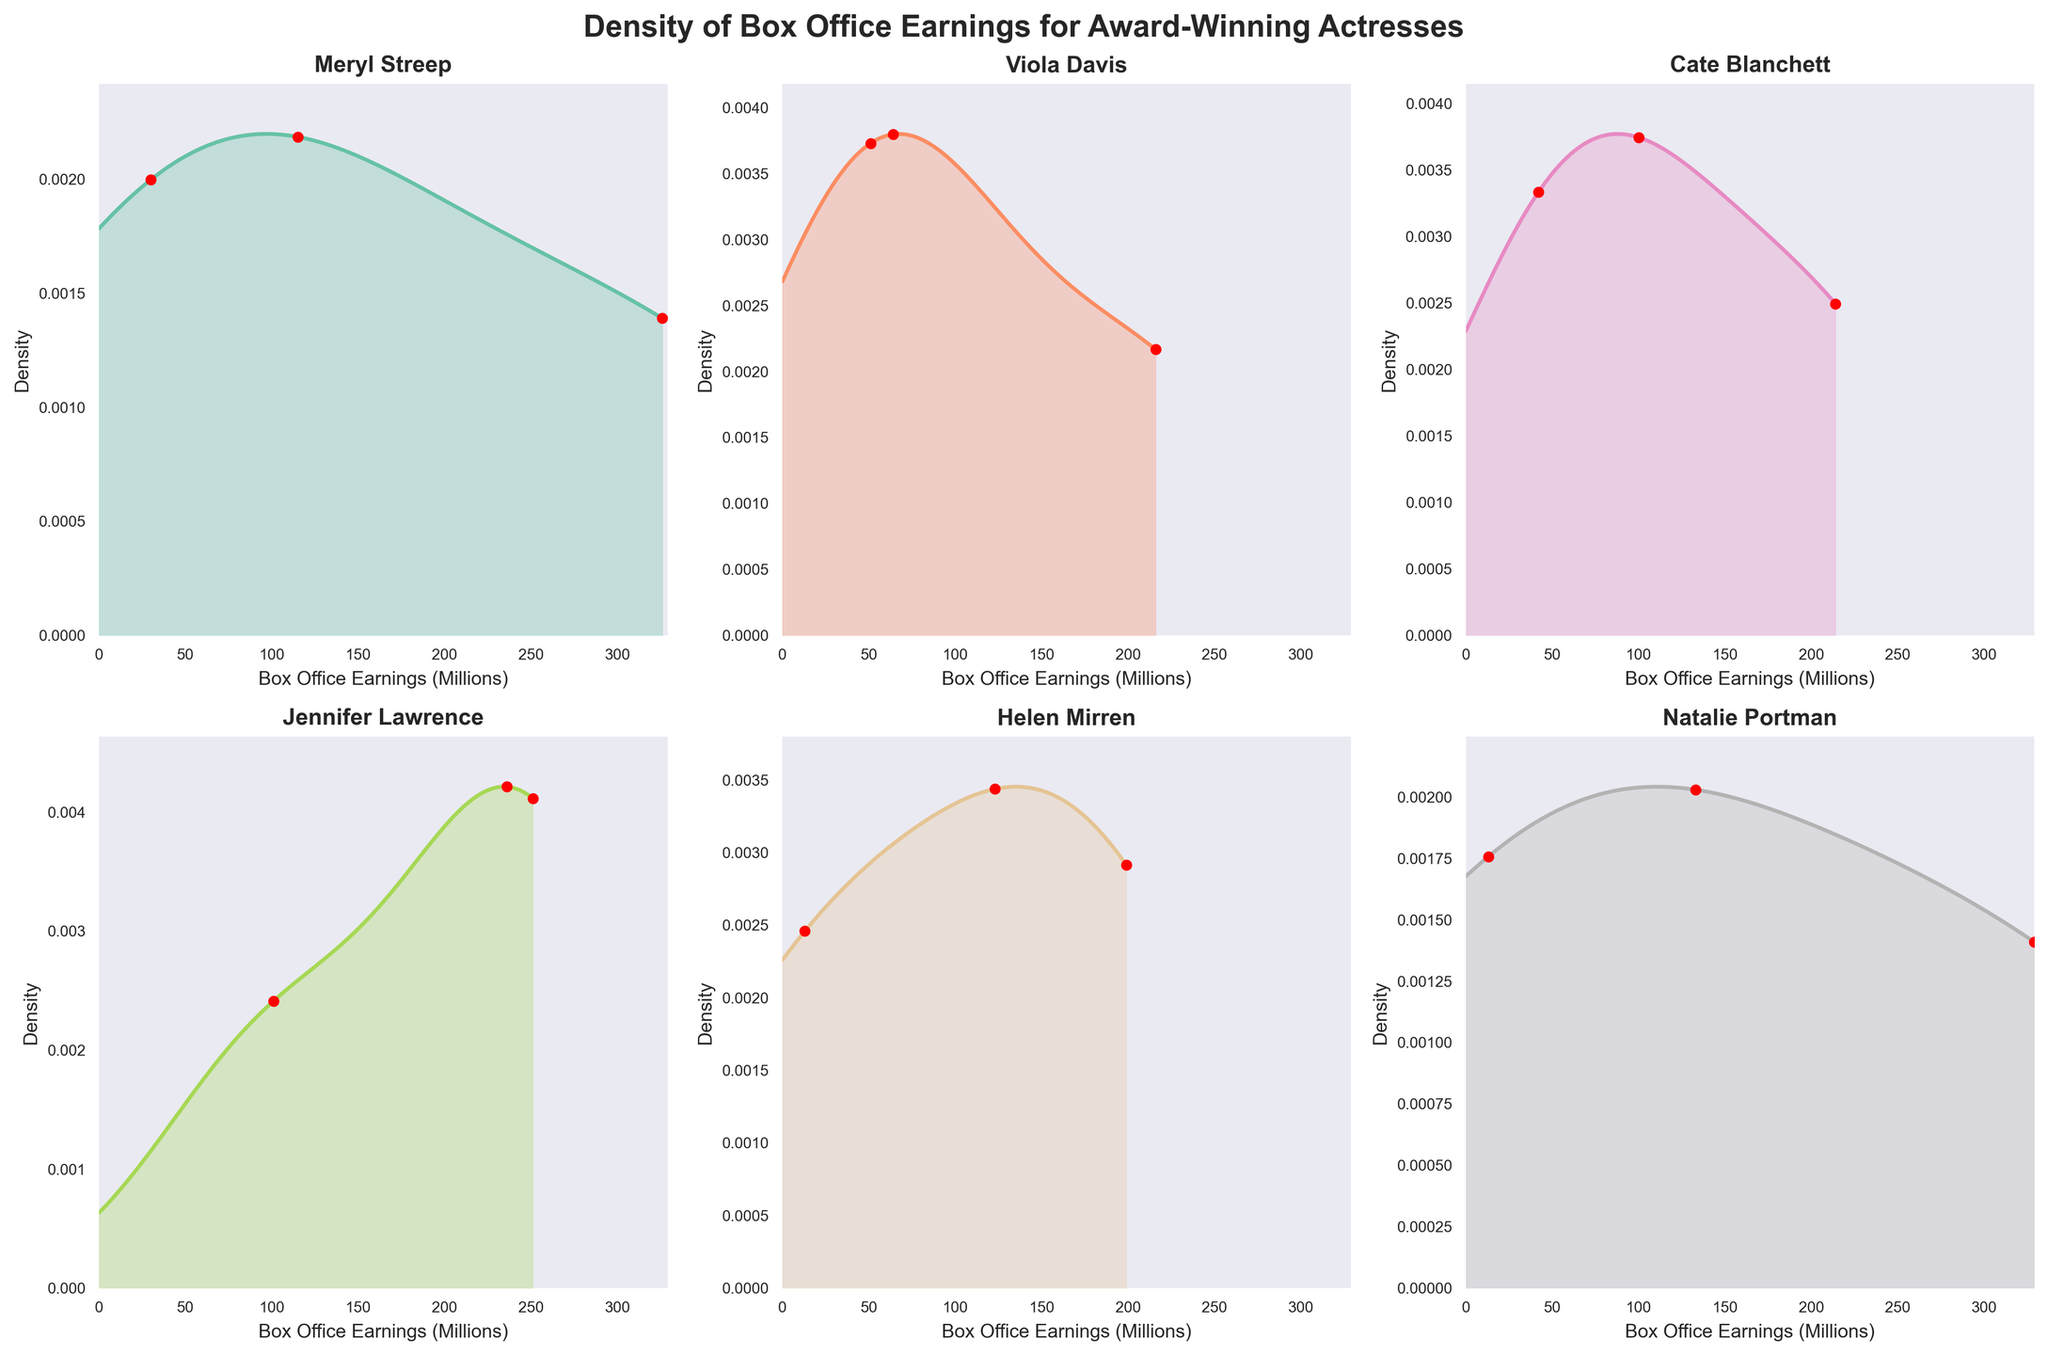Which actress has the highest density peak for box office earnings? By looking at the highest point on the density plots for each actress, we compare their values. The peak indicates the mode or most frequent value range.
Answer: Natalie Portman What are the box office earnings intervals where Meryl Streep's performances are most densely clustered? Identify the highest regions in Meryl Streep's density plot. These peaks represent intervals where her earnings are most frequent.
Answer: $30M and $326M How do Helen Mirren's box office earnings compare to those of Cate Blanchett in terms of density? Compare the shapes and peaks of the density plots for Helen Mirren and Cate Blanchett. Look for differences in density clusters and peak heights.
Answer: Helen Mirren has a wide spread of earnings while Cate Blanchett has a more balanced distribution Which actress has the widest spread in her box office earnings distribution? Examine the range spanned by each actress's density plot. The widest spread indicates the most variability in earnings.
Answer: Meryl Streep Between Viola Davis and Jennifer Lawrence, who has the higher density peak and what does this suggest about their earnings distribution? Compare the highest points (peaks) of the density plots for Viola Davis and Jennifer Lawrence. The higher density peak suggests more frequent earnings in that range.
Answer: Jennifer Lawrence Of all actresses, whose density plot suggests the most consistent box office performance? Consistency is indicated by a narrow, high peak in the density plot. Identify the actress with this feature in her plot.
Answer: Natalie Portman What density intervals overlap most between Cate Blanchett and Jennifer Lawrence? Compare the density plots for Cate Blanchett and Jennifer Lawrence to find areas where both plots have high density values.
Answer: $100M to $250M How is the density of earnings for Natalie Portman's most successful films reflected in the plot? Focus on the highest density region in Natalie Portman's plot, which represents her most successful box office intervals.
Answer: Around $329M Which actress has the most number of individual performance points widely scattered across the density plot? Examine the scatter points representing individual performances on each actress’s density plot. Identify the actress with the widest scatter of points.
Answer: Meryl Streep Considering the box office earnings densities, which actress has a density plot suggesting two distinct successful performance clusters? Identify the actress whose plot shows two clear, separate peaks. Each peak represents a cluster of successful performances.
Answer: Meryl Streep 